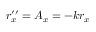<formula> <loc_0><loc_0><loc_500><loc_500>r _ { x } ^ { \prime \prime } = A _ { x } = - k r _ { x }</formula> 